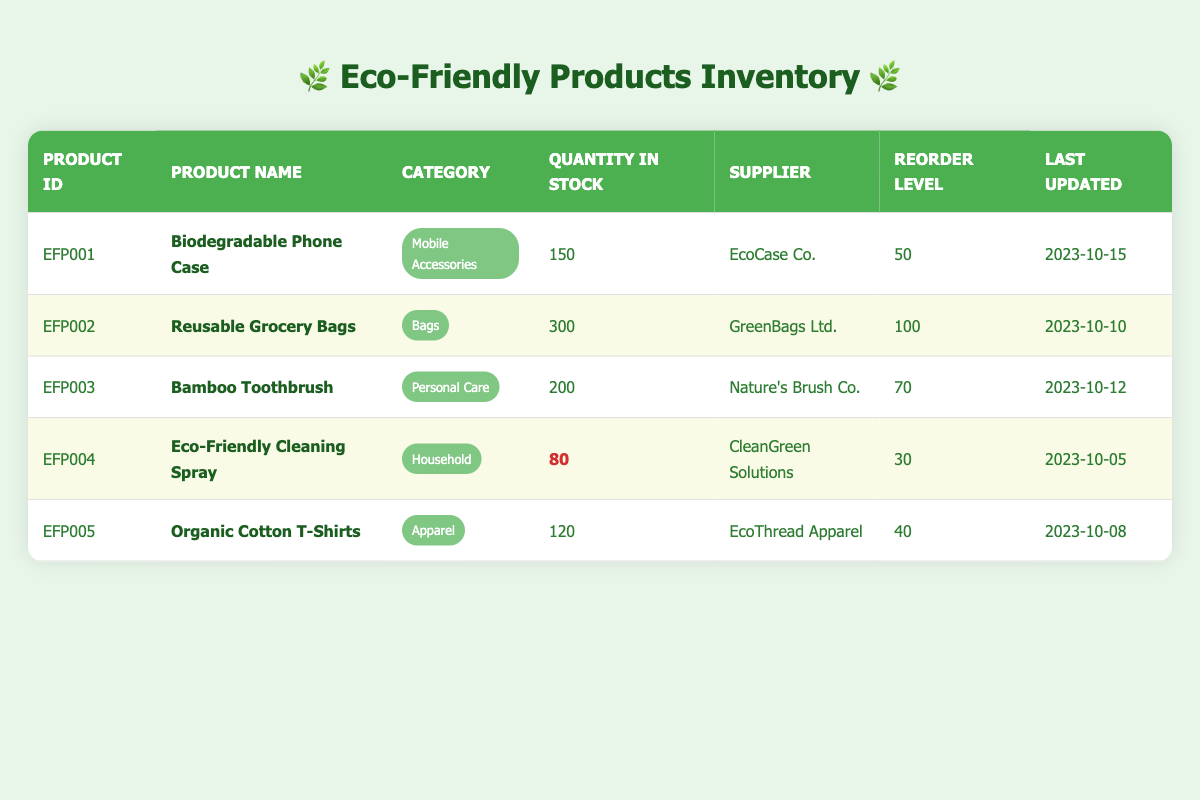What is the product name of EFP003? The product ID EFP003 corresponds to the product name listed in the table. By looking at the row for EFP003, we find that the product name is "Bamboo Toothbrush."
Answer: Bamboo Toothbrush How many Reusable Grocery Bags are in stock? The product ID for Reusable Grocery Bags is EFP002. Referring to the corresponding row in the table, we see that the quantity in stock is 300.
Answer: 300 Which product has the lowest quantity in stock? To determine this, I check the quantity in stock for all products. The Eco-Friendly Cleaning Spray (EFP004) has 80 units, which is the lowest among all listed products.
Answer: Eco-Friendly Cleaning Spray Is the quantity of Organic Cotton T-Shirts above its reorder level? The quantity in stock for Organic Cotton T-Shirts (EFP005) is 120 and its reorder level is 40. Since 120 is greater than 40, the statement is true.
Answer: Yes What is the total quantity of Mobile Accessories in stock? The only Mobile Accessory listed is the Biodegradable Phone Case (EFP001), with a stock of 150. Therefore, the total quantity of Mobile Accessories is 150, as there are no other products in this category.
Answer: 150 How many products have a quantity in stock below their reorder level? We look at each product's quantity in stock and compare it to its reorder level. The Eco-Friendly Cleaning Spray has 80 in stock and a reorder level of 30. Since this is the only product below its reorder level (noting that others are above or equal), the total count of such products is 1.
Answer: 1 What is the average quantity in stock for all products? To calculate the average, I sum the quantities: 150 (EFP001) + 300 (EFP002) + 200 (EFP003) + 80 (EFP004) + 120 (EFP005) = 850. Then, I divide the total (850) by the number of products (5), leading to an average of 170.
Answer: 170 Which supplier provides the maximum stock of products? I need to examine each product's stock and group them by supplier. GreenBags Ltd. supplies Reusable Grocery Bags (300), which is the highest quantity compared to others, hence it provides the maximum stock.
Answer: GreenBags Ltd Is there more than one product categorized under "Personal Care"? Only one product falls under the Personal Care category, which is the Bamboo Toothbrush (EFP003). Thus, the answer is negative.
Answer: No 